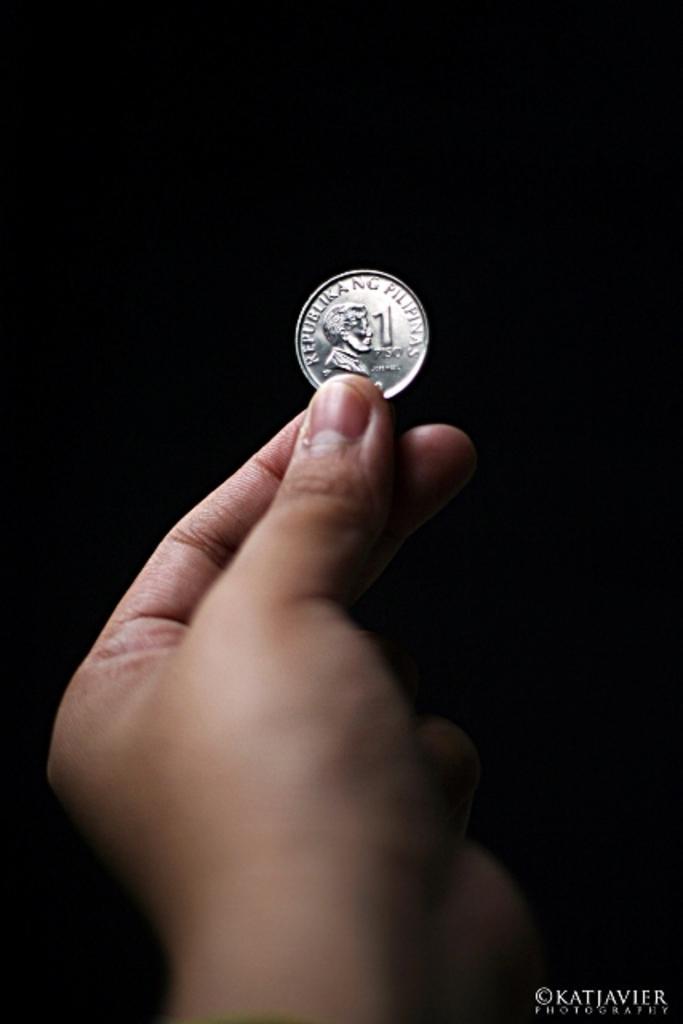In one or two sentences, can you explain what this image depicts? In this image I can see the person holding a coin and I can see the dark background. 